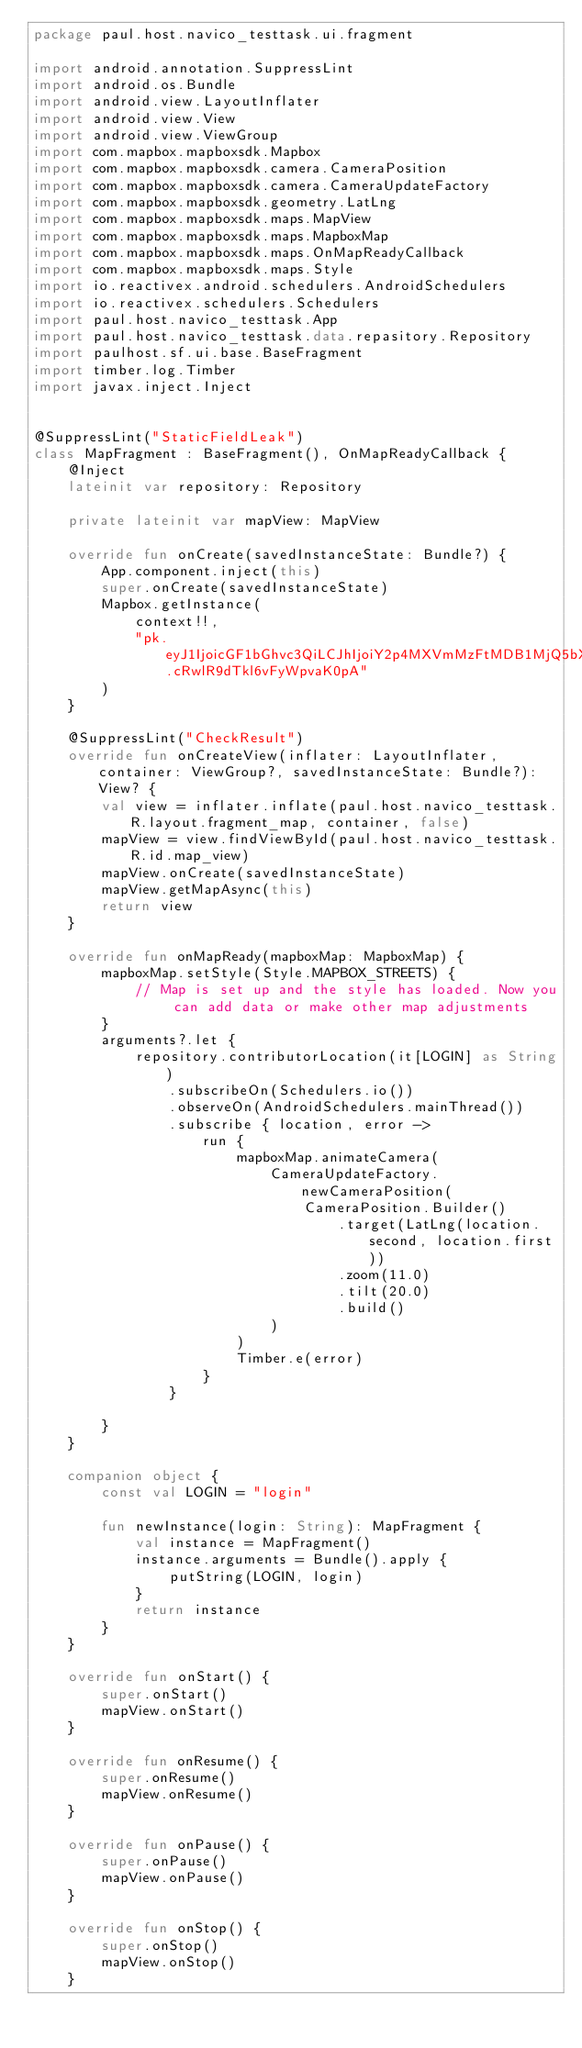<code> <loc_0><loc_0><loc_500><loc_500><_Kotlin_>package paul.host.navico_testtask.ui.fragment

import android.annotation.SuppressLint
import android.os.Bundle
import android.view.LayoutInflater
import android.view.View
import android.view.ViewGroup
import com.mapbox.mapboxsdk.Mapbox
import com.mapbox.mapboxsdk.camera.CameraPosition
import com.mapbox.mapboxsdk.camera.CameraUpdateFactory
import com.mapbox.mapboxsdk.geometry.LatLng
import com.mapbox.mapboxsdk.maps.MapView
import com.mapbox.mapboxsdk.maps.MapboxMap
import com.mapbox.mapboxsdk.maps.OnMapReadyCallback
import com.mapbox.mapboxsdk.maps.Style
import io.reactivex.android.schedulers.AndroidSchedulers
import io.reactivex.schedulers.Schedulers
import paul.host.navico_testtask.App
import paul.host.navico_testtask.data.repasitory.Repository
import paulhost.sf.ui.base.BaseFragment
import timber.log.Timber
import javax.inject.Inject


@SuppressLint("StaticFieldLeak")
class MapFragment : BaseFragment(), OnMapReadyCallback {
    @Inject
    lateinit var repository: Repository

    private lateinit var mapView: MapView

    override fun onCreate(savedInstanceState: Bundle?) {
        App.component.inject(this)
        super.onCreate(savedInstanceState)
        Mapbox.getInstance(
            context!!,
            "pk.eyJ1IjoicGF1bGhvc3QiLCJhIjoiY2p4MXVmMzFtMDB1MjQ5bXk2aTMwc3IzdSJ9.cRwlR9dTkl6vFyWpvaK0pA"
        )
    }

    @SuppressLint("CheckResult")
    override fun onCreateView(inflater: LayoutInflater, container: ViewGroup?, savedInstanceState: Bundle?): View? {
        val view = inflater.inflate(paul.host.navico_testtask.R.layout.fragment_map, container, false)
        mapView = view.findViewById(paul.host.navico_testtask.R.id.map_view)
        mapView.onCreate(savedInstanceState)
        mapView.getMapAsync(this)
        return view
    }

    override fun onMapReady(mapboxMap: MapboxMap) {
        mapboxMap.setStyle(Style.MAPBOX_STREETS) {
            // Map is set up and the style has loaded. Now you can add data or make other map adjustments
        }
        arguments?.let {
            repository.contributorLocation(it[LOGIN] as String)
                .subscribeOn(Schedulers.io())
                .observeOn(AndroidSchedulers.mainThread())
                .subscribe { location, error ->
                    run {
                        mapboxMap.animateCamera(
                            CameraUpdateFactory.newCameraPosition(
                                CameraPosition.Builder()
                                    .target(LatLng(location.second, location.first))
                                    .zoom(11.0)
                                    .tilt(20.0)
                                    .build()
                            )
                        )
                        Timber.e(error)
                    }
                }

        }
    }

    companion object {
        const val LOGIN = "login"

        fun newInstance(login: String): MapFragment {
            val instance = MapFragment()
            instance.arguments = Bundle().apply {
                putString(LOGIN, login)
            }
            return instance
        }
    }

    override fun onStart() {
        super.onStart()
        mapView.onStart()
    }

    override fun onResume() {
        super.onResume()
        mapView.onResume()
    }

    override fun onPause() {
        super.onPause()
        mapView.onPause()
    }

    override fun onStop() {
        super.onStop()
        mapView.onStop()
    }
</code> 